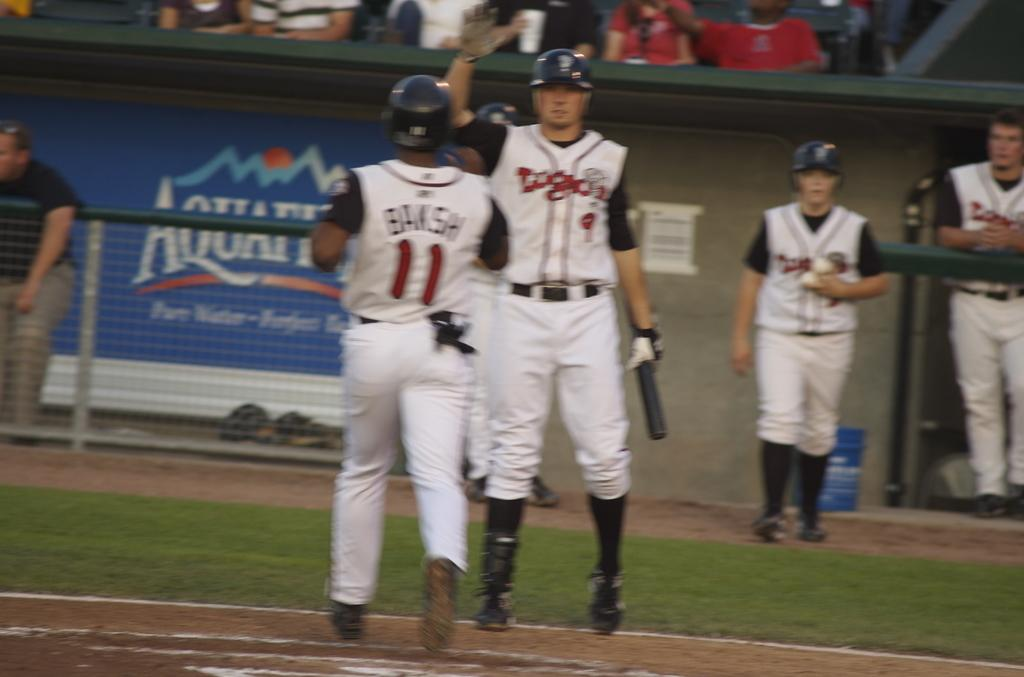<image>
Share a concise interpretation of the image provided. Two baseball players approach each other to high five in front of an Aquifina sign. 